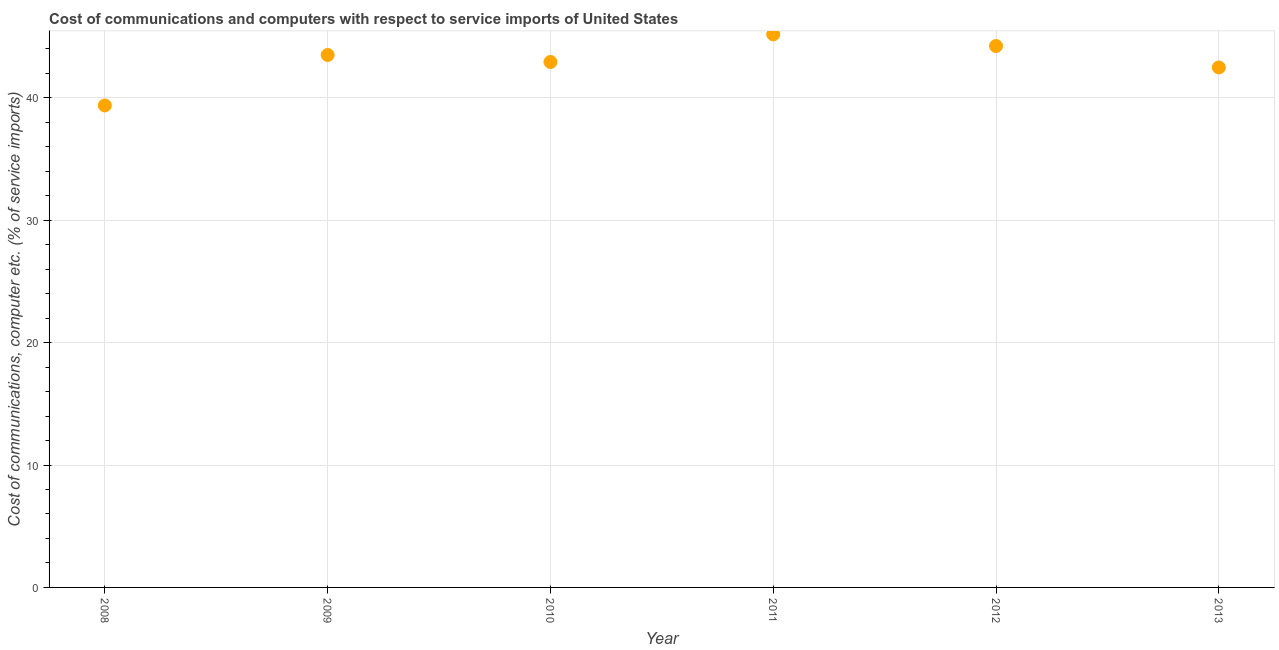What is the cost of communications and computer in 2008?
Give a very brief answer. 39.38. Across all years, what is the maximum cost of communications and computer?
Your response must be concise. 45.19. Across all years, what is the minimum cost of communications and computer?
Provide a succinct answer. 39.38. What is the sum of the cost of communications and computer?
Make the answer very short. 257.74. What is the difference between the cost of communications and computer in 2010 and 2013?
Provide a short and direct response. 0.45. What is the average cost of communications and computer per year?
Offer a very short reply. 42.96. What is the median cost of communications and computer?
Your answer should be compact. 43.22. In how many years, is the cost of communications and computer greater than 10 %?
Give a very brief answer. 6. What is the ratio of the cost of communications and computer in 2008 to that in 2009?
Ensure brevity in your answer.  0.91. What is the difference between the highest and the second highest cost of communications and computer?
Provide a short and direct response. 0.95. Is the sum of the cost of communications and computer in 2009 and 2013 greater than the maximum cost of communications and computer across all years?
Offer a terse response. Yes. What is the difference between the highest and the lowest cost of communications and computer?
Give a very brief answer. 5.81. In how many years, is the cost of communications and computer greater than the average cost of communications and computer taken over all years?
Offer a terse response. 3. How many dotlines are there?
Your answer should be very brief. 1. How many years are there in the graph?
Offer a terse response. 6. What is the difference between two consecutive major ticks on the Y-axis?
Your answer should be compact. 10. Does the graph contain any zero values?
Make the answer very short. No. Does the graph contain grids?
Your response must be concise. Yes. What is the title of the graph?
Ensure brevity in your answer.  Cost of communications and computers with respect to service imports of United States. What is the label or title of the Y-axis?
Make the answer very short. Cost of communications, computer etc. (% of service imports). What is the Cost of communications, computer etc. (% of service imports) in 2008?
Your answer should be compact. 39.38. What is the Cost of communications, computer etc. (% of service imports) in 2009?
Your answer should be very brief. 43.51. What is the Cost of communications, computer etc. (% of service imports) in 2010?
Provide a short and direct response. 42.93. What is the Cost of communications, computer etc. (% of service imports) in 2011?
Keep it short and to the point. 45.19. What is the Cost of communications, computer etc. (% of service imports) in 2012?
Offer a very short reply. 44.24. What is the Cost of communications, computer etc. (% of service imports) in 2013?
Ensure brevity in your answer.  42.49. What is the difference between the Cost of communications, computer etc. (% of service imports) in 2008 and 2009?
Ensure brevity in your answer.  -4.12. What is the difference between the Cost of communications, computer etc. (% of service imports) in 2008 and 2010?
Offer a terse response. -3.55. What is the difference between the Cost of communications, computer etc. (% of service imports) in 2008 and 2011?
Give a very brief answer. -5.81. What is the difference between the Cost of communications, computer etc. (% of service imports) in 2008 and 2012?
Make the answer very short. -4.85. What is the difference between the Cost of communications, computer etc. (% of service imports) in 2008 and 2013?
Make the answer very short. -3.1. What is the difference between the Cost of communications, computer etc. (% of service imports) in 2009 and 2010?
Keep it short and to the point. 0.57. What is the difference between the Cost of communications, computer etc. (% of service imports) in 2009 and 2011?
Offer a terse response. -1.68. What is the difference between the Cost of communications, computer etc. (% of service imports) in 2009 and 2012?
Provide a short and direct response. -0.73. What is the difference between the Cost of communications, computer etc. (% of service imports) in 2009 and 2013?
Give a very brief answer. 1.02. What is the difference between the Cost of communications, computer etc. (% of service imports) in 2010 and 2011?
Keep it short and to the point. -2.26. What is the difference between the Cost of communications, computer etc. (% of service imports) in 2010 and 2012?
Keep it short and to the point. -1.3. What is the difference between the Cost of communications, computer etc. (% of service imports) in 2010 and 2013?
Keep it short and to the point. 0.45. What is the difference between the Cost of communications, computer etc. (% of service imports) in 2011 and 2012?
Ensure brevity in your answer.  0.95. What is the difference between the Cost of communications, computer etc. (% of service imports) in 2011 and 2013?
Provide a succinct answer. 2.7. What is the difference between the Cost of communications, computer etc. (% of service imports) in 2012 and 2013?
Your response must be concise. 1.75. What is the ratio of the Cost of communications, computer etc. (% of service imports) in 2008 to that in 2009?
Provide a succinct answer. 0.91. What is the ratio of the Cost of communications, computer etc. (% of service imports) in 2008 to that in 2010?
Offer a very short reply. 0.92. What is the ratio of the Cost of communications, computer etc. (% of service imports) in 2008 to that in 2011?
Give a very brief answer. 0.87. What is the ratio of the Cost of communications, computer etc. (% of service imports) in 2008 to that in 2012?
Your answer should be very brief. 0.89. What is the ratio of the Cost of communications, computer etc. (% of service imports) in 2008 to that in 2013?
Offer a very short reply. 0.93. What is the ratio of the Cost of communications, computer etc. (% of service imports) in 2009 to that in 2010?
Your response must be concise. 1.01. What is the ratio of the Cost of communications, computer etc. (% of service imports) in 2009 to that in 2011?
Your response must be concise. 0.96. What is the ratio of the Cost of communications, computer etc. (% of service imports) in 2009 to that in 2013?
Your answer should be very brief. 1.02. What is the ratio of the Cost of communications, computer etc. (% of service imports) in 2010 to that in 2011?
Offer a terse response. 0.95. What is the ratio of the Cost of communications, computer etc. (% of service imports) in 2010 to that in 2012?
Ensure brevity in your answer.  0.97. What is the ratio of the Cost of communications, computer etc. (% of service imports) in 2010 to that in 2013?
Provide a short and direct response. 1.01. What is the ratio of the Cost of communications, computer etc. (% of service imports) in 2011 to that in 2013?
Ensure brevity in your answer.  1.06. What is the ratio of the Cost of communications, computer etc. (% of service imports) in 2012 to that in 2013?
Provide a succinct answer. 1.04. 